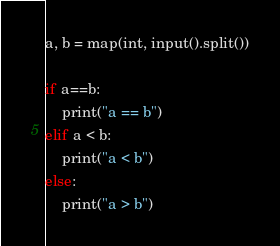Convert code to text. <code><loc_0><loc_0><loc_500><loc_500><_Python_>a, b = map(int, input().split())

if a==b:
    print("a == b")
elif a < b:
    print("a < b")
else:
    print("a > b")
</code> 